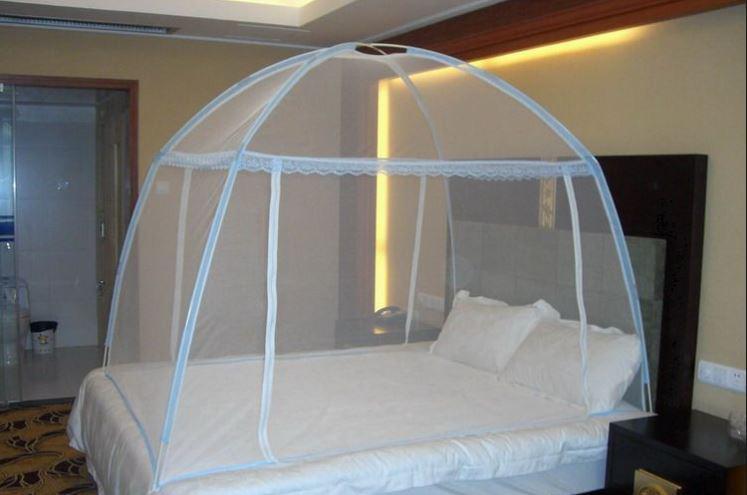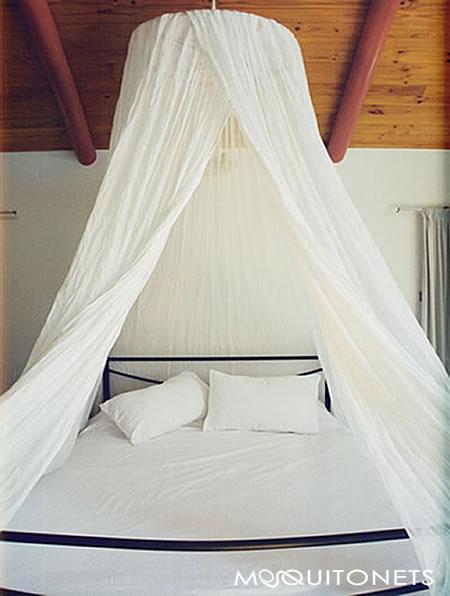The first image is the image on the left, the second image is the image on the right. Considering the images on both sides, is "One canopy is square shaped." valid? Answer yes or no. No. 